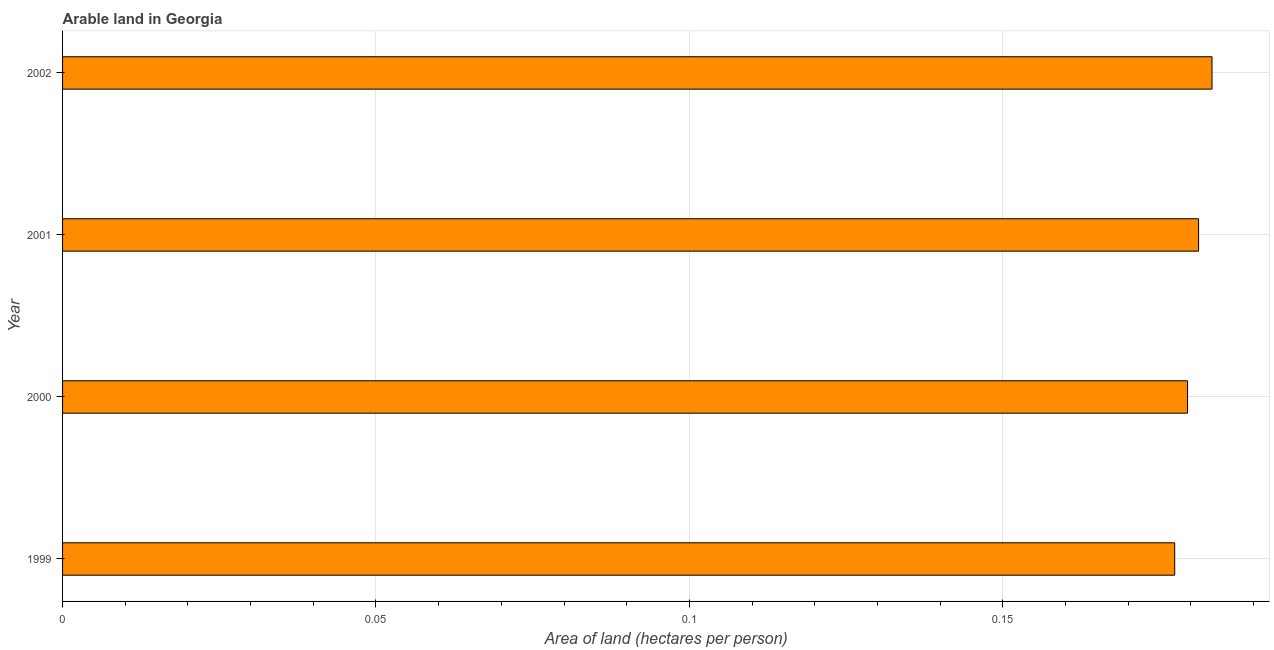Does the graph contain any zero values?
Keep it short and to the point. No. What is the title of the graph?
Ensure brevity in your answer.  Arable land in Georgia. What is the label or title of the X-axis?
Provide a succinct answer. Area of land (hectares per person). What is the area of arable land in 1999?
Keep it short and to the point. 0.18. Across all years, what is the maximum area of arable land?
Ensure brevity in your answer.  0.18. Across all years, what is the minimum area of arable land?
Provide a short and direct response. 0.18. What is the sum of the area of arable land?
Your answer should be very brief. 0.72. What is the difference between the area of arable land in 2000 and 2001?
Your answer should be compact. -0. What is the average area of arable land per year?
Give a very brief answer. 0.18. What is the median area of arable land?
Your response must be concise. 0.18. In how many years, is the area of arable land greater than 0.06 hectares per person?
Keep it short and to the point. 4. What is the ratio of the area of arable land in 2000 to that in 2001?
Make the answer very short. 0.99. Is the difference between the area of arable land in 2001 and 2002 greater than the difference between any two years?
Offer a very short reply. No. What is the difference between the highest and the second highest area of arable land?
Provide a succinct answer. 0. Is the sum of the area of arable land in 2001 and 2002 greater than the maximum area of arable land across all years?
Offer a very short reply. Yes. In how many years, is the area of arable land greater than the average area of arable land taken over all years?
Give a very brief answer. 2. How many years are there in the graph?
Keep it short and to the point. 4. What is the difference between two consecutive major ticks on the X-axis?
Provide a succinct answer. 0.05. What is the Area of land (hectares per person) of 1999?
Keep it short and to the point. 0.18. What is the Area of land (hectares per person) in 2000?
Your answer should be very brief. 0.18. What is the Area of land (hectares per person) of 2001?
Provide a short and direct response. 0.18. What is the Area of land (hectares per person) in 2002?
Your answer should be compact. 0.18. What is the difference between the Area of land (hectares per person) in 1999 and 2000?
Your response must be concise. -0. What is the difference between the Area of land (hectares per person) in 1999 and 2001?
Your answer should be very brief. -0. What is the difference between the Area of land (hectares per person) in 1999 and 2002?
Give a very brief answer. -0.01. What is the difference between the Area of land (hectares per person) in 2000 and 2001?
Make the answer very short. -0. What is the difference between the Area of land (hectares per person) in 2000 and 2002?
Your response must be concise. -0. What is the difference between the Area of land (hectares per person) in 2001 and 2002?
Give a very brief answer. -0. What is the ratio of the Area of land (hectares per person) in 1999 to that in 2000?
Provide a short and direct response. 0.99. What is the ratio of the Area of land (hectares per person) in 1999 to that in 2001?
Keep it short and to the point. 0.98. What is the ratio of the Area of land (hectares per person) in 1999 to that in 2002?
Offer a terse response. 0.97. What is the ratio of the Area of land (hectares per person) in 2000 to that in 2002?
Provide a short and direct response. 0.98. What is the ratio of the Area of land (hectares per person) in 2001 to that in 2002?
Your answer should be very brief. 0.99. 